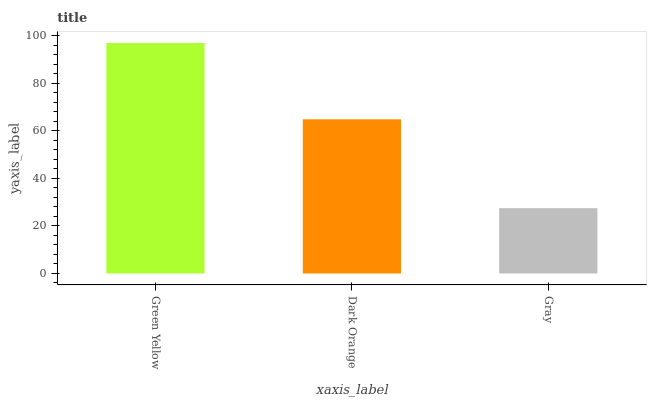Is Gray the minimum?
Answer yes or no. Yes. Is Green Yellow the maximum?
Answer yes or no. Yes. Is Dark Orange the minimum?
Answer yes or no. No. Is Dark Orange the maximum?
Answer yes or no. No. Is Green Yellow greater than Dark Orange?
Answer yes or no. Yes. Is Dark Orange less than Green Yellow?
Answer yes or no. Yes. Is Dark Orange greater than Green Yellow?
Answer yes or no. No. Is Green Yellow less than Dark Orange?
Answer yes or no. No. Is Dark Orange the high median?
Answer yes or no. Yes. Is Dark Orange the low median?
Answer yes or no. Yes. Is Gray the high median?
Answer yes or no. No. Is Green Yellow the low median?
Answer yes or no. No. 